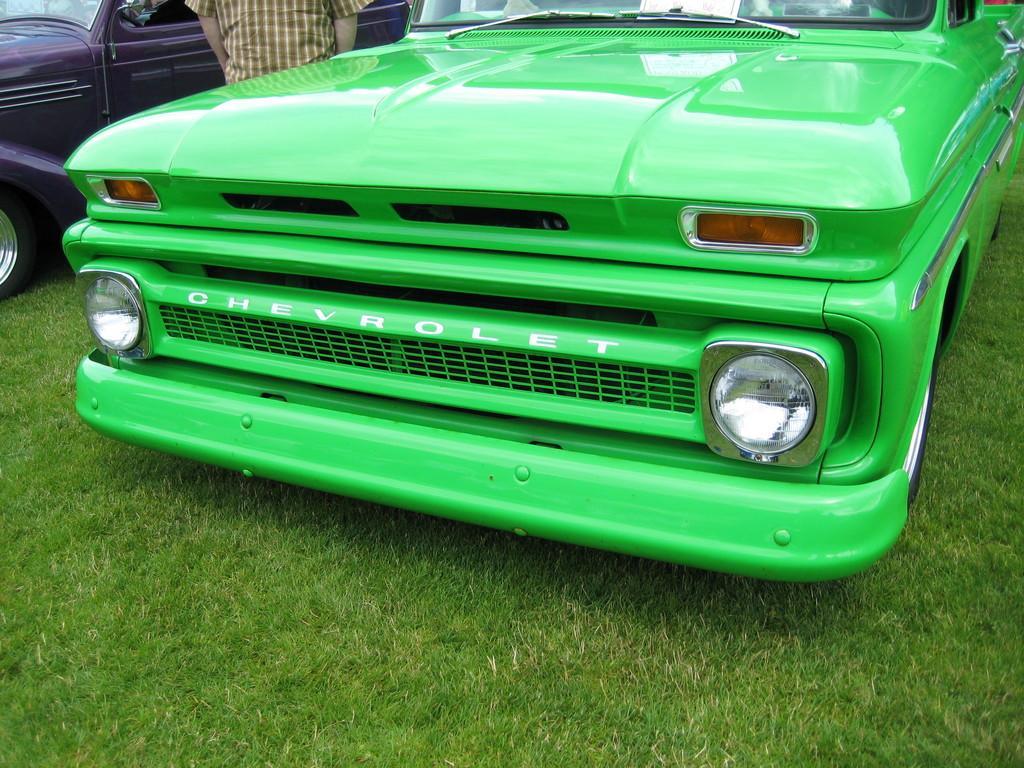In one or two sentences, can you explain what this image depicts? In this image we can see vehicles and a person. At the bottom of the image there is the grass. 